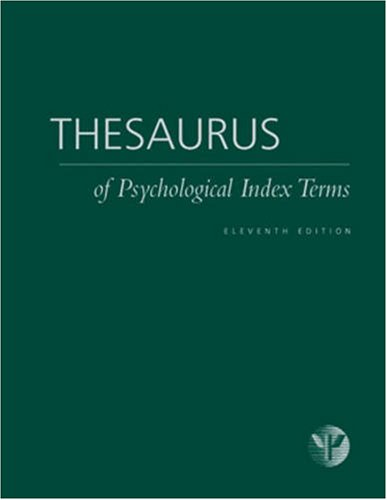How might this book be useful for a psychology student? This thesaurus is a valuable tool for psychology students as it provides clear definitions and the relationships between psychological terms. This can aid in understanding complex concepts and theories, improving their academic writing and comprehension of the discipline. Can it be used by professionals outside academia, like practicing psychologists? Absolutely, practicing psychologists can use this thesaurus to ensure clarity and accuracy in their reports, assessments, and communications. It serves as a quick reference to maintain consistency in terminology within professional practices. 